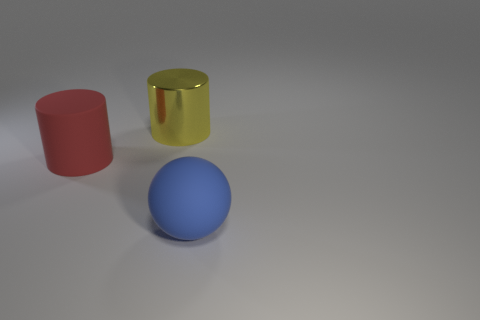Add 2 matte objects. How many objects exist? 5 Subtract all balls. How many objects are left? 2 Subtract all large blue objects. Subtract all tiny cyan blocks. How many objects are left? 2 Add 2 big matte balls. How many big matte balls are left? 3 Add 2 metal objects. How many metal objects exist? 3 Subtract 0 cyan blocks. How many objects are left? 3 